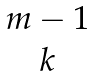Convert formula to latex. <formula><loc_0><loc_0><loc_500><loc_500>\begin{matrix} m - 1 \\ k \end{matrix}</formula> 